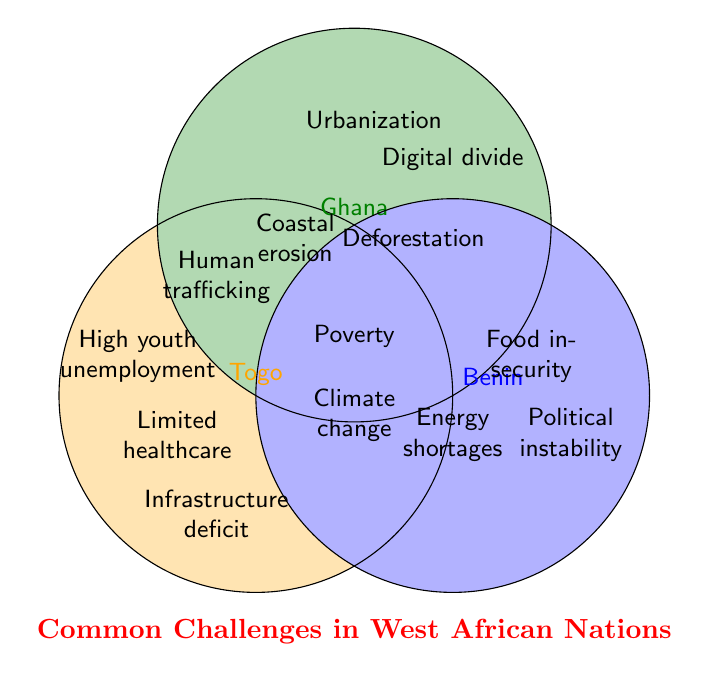What is the unique challenge faced by Togo that's not shared by Ghana or Benin? Togo's unique challenges are those that fall only within the Togo circle and not intersecting with Ghana or Benin. The challenge listed here is "High youth unemployment."
Answer: High youth unemployment Which countries share the challenge of coastal erosion? Look at the intersection areas that have the label "Coastal erosion." This label is in the section shared by both Togo and Ghana.
Answer: Togo and Ghana Is "Food insecurity" a shared challenge among the countries? Check if the challenge "Food insecurity" appears in any of the intersection areas. It is only in the area exclusively for Benin.
Answer: No List all challenges that are shared among Togo, Ghana, and Benin. Challenges shared by all three countries are located in the center where all three circles intersect. These are labeled as "Poverty" and "Climate change impacts."
Answer: Poverty, Climate change impacts Which country faces "Digital divide" and "Urbanization pressures"? These labels are in the circle representing Ghana and not intersecting with any other circles.
Answer: Ghana What are the shared challenges between Ghana and Benin, excluding those shared by all three countries? Look for the intersection area shared by Ghana and Benin but not overlapping with Togo. The challenge listed here is "Deforestation."
Answer: Deforestation Which unique challenges does Benin face compared to Togo and Ghana? Benin's unique challenges are those listed in its circle that do not intersect with the circles for Togo or Ghana. These include "Food insecurity" and "Political instability."
Answer: Food insecurity, Political instability Which challenges are shared only by Togo and Benin? Look for challenges listed in the intersection area specific to Togo and Benin but not intersecting with Ghana. The challenge listed here is "Energy shortages."
Answer: Energy shortages What is the most common challenge shared among the countries shown? The most common challenges are those that appear in the intersection area shared by all three countries. These are "Poverty" and "Climate change impacts."
Answer: Poverty, Climate change impacts 